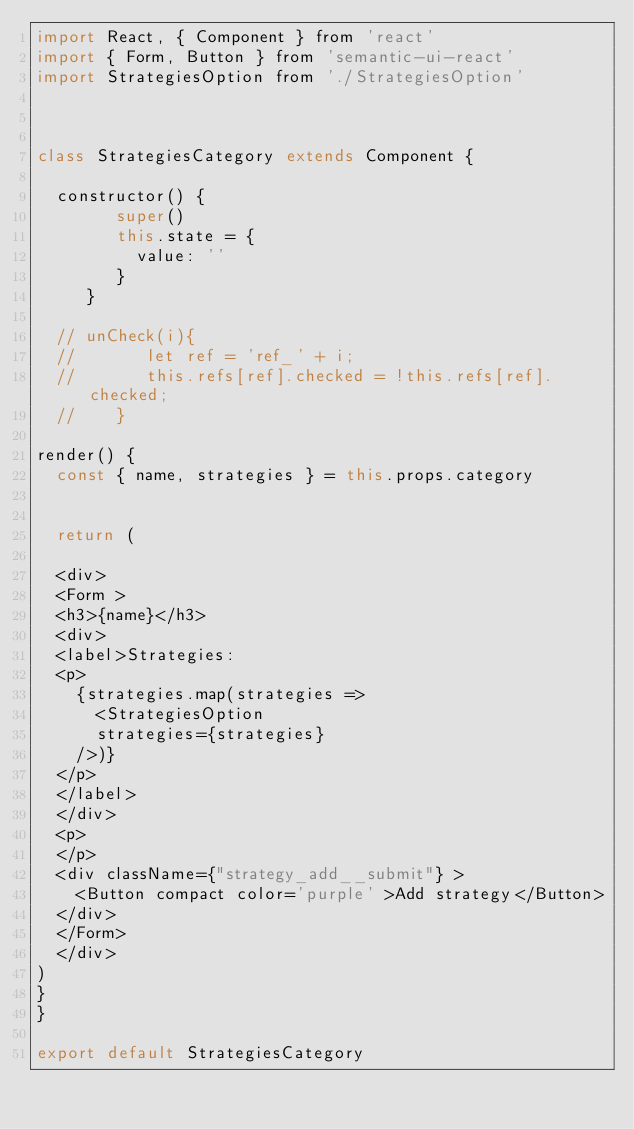Convert code to text. <code><loc_0><loc_0><loc_500><loc_500><_JavaScript_>import React, { Component } from 'react'
import { Form, Button } from 'semantic-ui-react'
import StrategiesOption from './StrategiesOption'



class StrategiesCategory extends Component {

  constructor() {
        super()
        this.state = {
          value: ''
        }
     }

  // unCheck(i){
  //       let ref = 'ref_' + i;
  //       this.refs[ref].checked = !this.refs[ref].checked;
  //    }

render() {
  const { name, strategies } = this.props.category


  return (

  <div>
  <Form >
  <h3>{name}</h3>
  <div>
  <label>Strategies:
  <p>
    {strategies.map(strategies =>
      <StrategiesOption
      strategies={strategies}
    />)}
  </p>
  </label>
  </div>
  <p>
  </p>
  <div className={"strategy_add__submit"} >
    <Button compact color='purple' >Add strategy</Button>
  </div>
  </Form>
  </div>
)
}
}

export default StrategiesCategory
</code> 